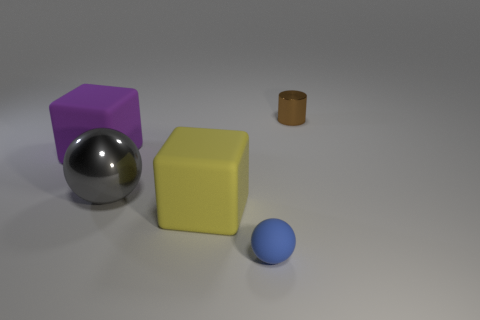Add 3 metallic cylinders. How many objects exist? 8 Subtract all gray spheres. How many spheres are left? 1 Subtract all cubes. How many objects are left? 3 Subtract all green cylinders. How many blue spheres are left? 1 Subtract all matte balls. Subtract all tiny metallic things. How many objects are left? 3 Add 1 large gray spheres. How many large gray spheres are left? 2 Add 5 tiny brown rubber blocks. How many tiny brown rubber blocks exist? 5 Subtract 1 purple blocks. How many objects are left? 4 Subtract 2 spheres. How many spheres are left? 0 Subtract all blue cylinders. Subtract all gray cubes. How many cylinders are left? 1 